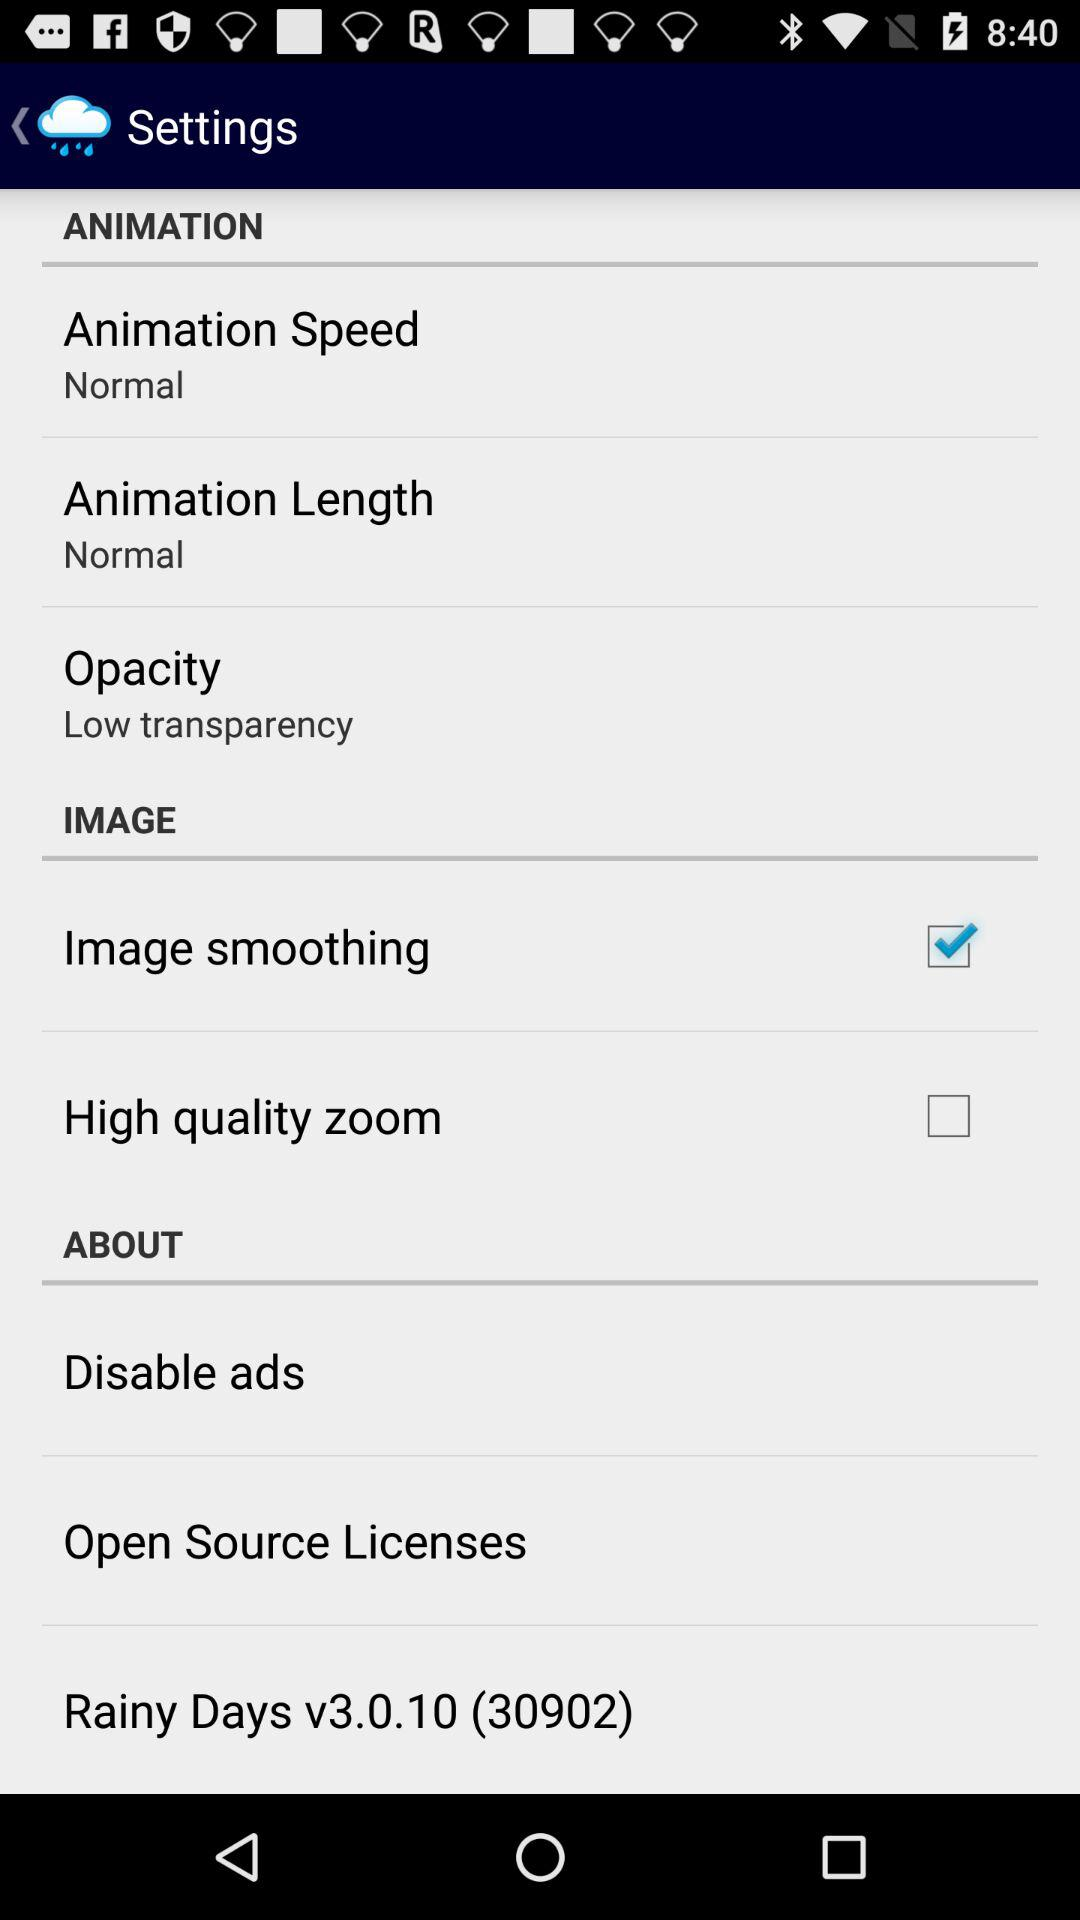What is the opacity? The opacity is "Low transparency". 